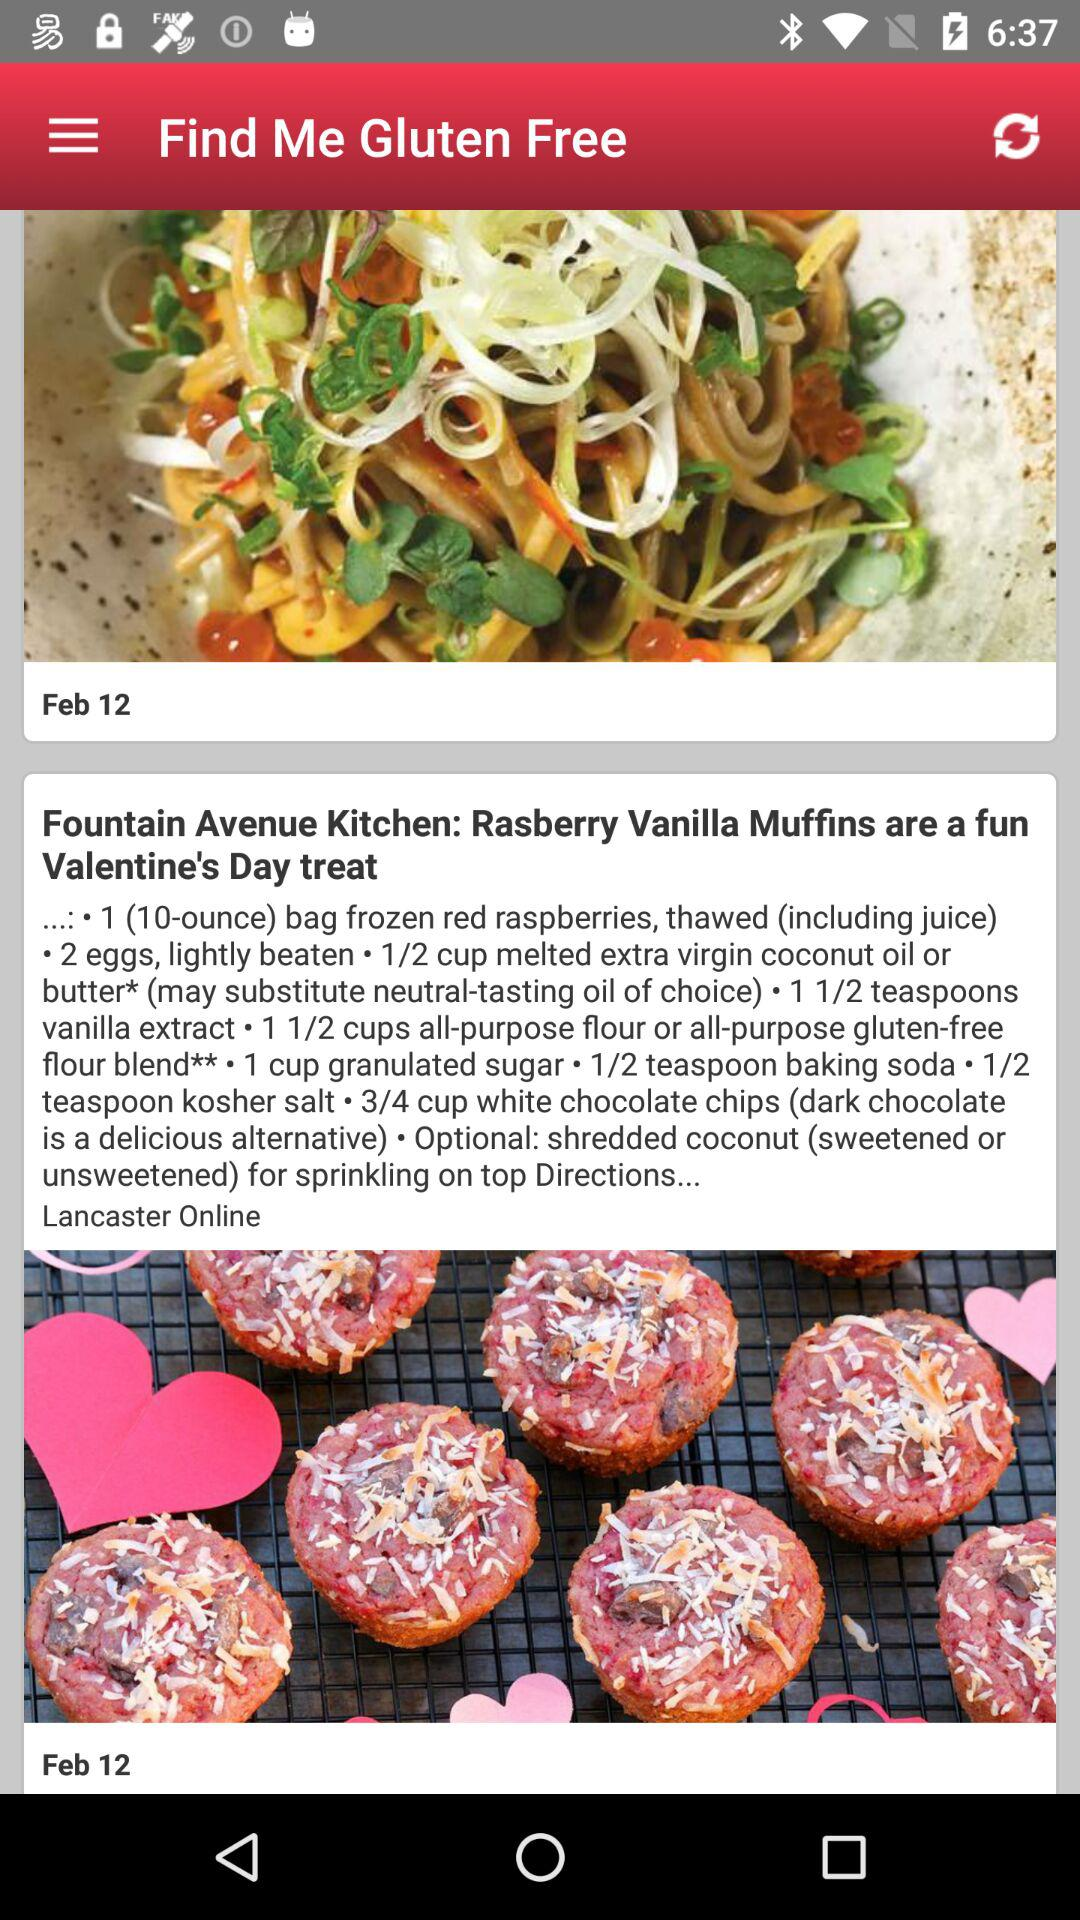How many cups of white chocolate chips are needed for the dish? There are 3/4 cups of white chocolate chips needed for the dish. 